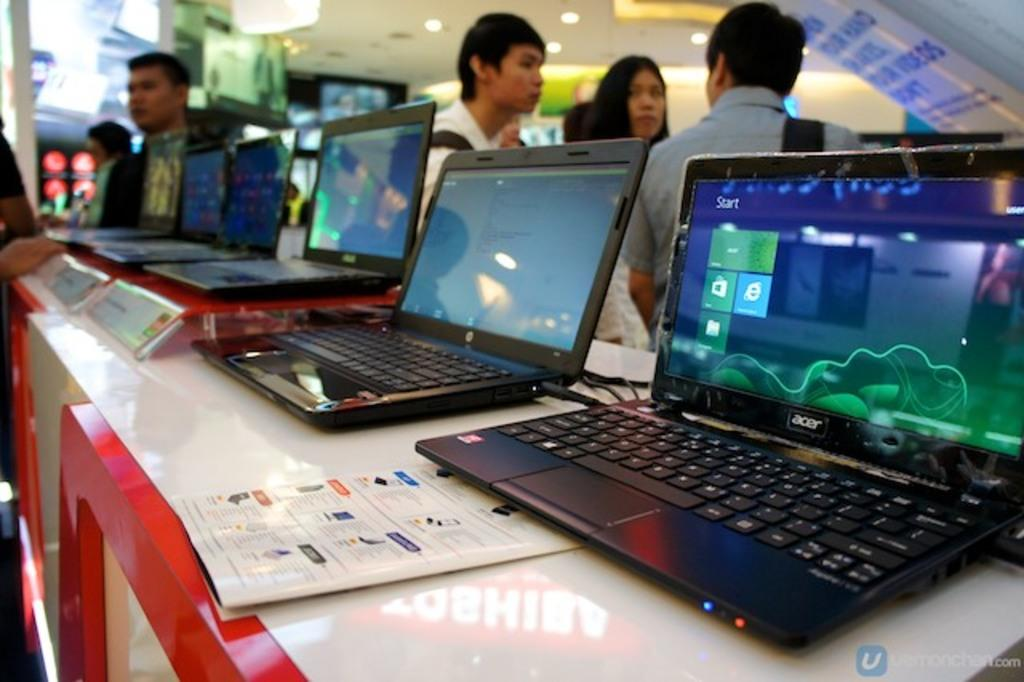What objects are on the table in the image? There are laptops on a table in the image. What can be seen in the background of the image? There are persons, monitors, and lights in the background of the image. What type of sock is the mom wearing in the image? There is no mom or sock present in the image. 